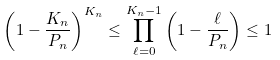Convert formula to latex. <formula><loc_0><loc_0><loc_500><loc_500>\left ( 1 - \frac { K _ { n } } { P _ { n } } \right ) ^ { K _ { n } } \leq \prod _ { \ell = 0 } ^ { K _ { n } - 1 } \left ( 1 - \frac { \ell } { P _ { n } } \right ) \leq 1</formula> 